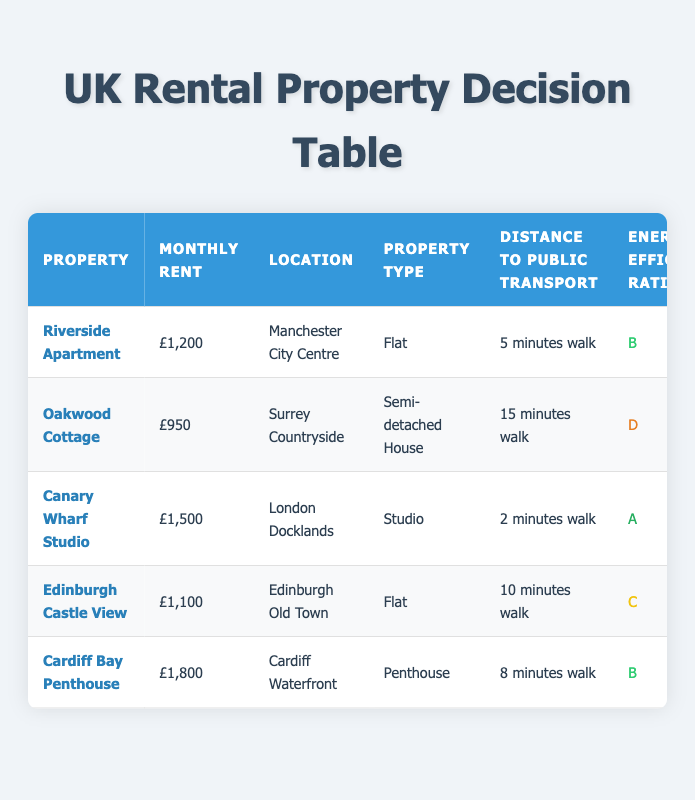What is the monthly rent for the Riverside Apartment? The monthly rent for the Riverside Apartment is listed as £1,200 in the table.
Answer: £1,200 Which property has the highest energy efficiency rating? The Canary Wharf Studio has the highest energy efficiency rating at 'A', while the others have ratings ranging from 'B' to 'D'.
Answer: Canary Wharf Studio Is parking available for the Oakwood Cottage? The table indicates that Oakwood Cottage has a "Private Driveway" for parking, meaning parking is available.
Answer: Yes What is the average monthly rent of the properties listed? The monthly rents are £1,200, £950, £1,500, £1,100, and £1,800. Adding these amounts gives £1,200 + £950 + £1,500 + £1,100 + £1,800 = £6,550. There are 5 properties, so the average monthly rent is £6,550 / 5 = £1,310.
Answer: £1,310 Which property allows pets and is fully furnished? The Cardiff Bay Penthouse is the only property that allows pets (as noted in the pet policy) and is also fully furnished.
Answer: Cardiff Bay Penthouse How many properties are located in city centre areas? Two properties are located in city centre areas: Riverside Apartment in Manchester City Centre and Canary Wharf Studio in London Docklands. Therefore, there are 2 properties in city centres.
Answer: 2 What contract length is available for the Cardiff Bay Penthouse? The contract length for the Cardiff Bay Penthouse is noted as 18 months within the table.
Answer: 18 months Which property has both excellent proximity to amenities and parking space? The Cardiff Bay Penthouse has "Excellent" proximity to amenities and "Allocated Space" for parking, fulfilling both criteria.
Answer: Cardiff Bay Penthouse Is there any property in the table that has a contract length of less than 12 months? Yes, the Canary Wharf Studio offers a contract length of 6 months, which is less than 12 months.
Answer: Yes 